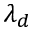Convert formula to latex. <formula><loc_0><loc_0><loc_500><loc_500>\lambda _ { d }</formula> 